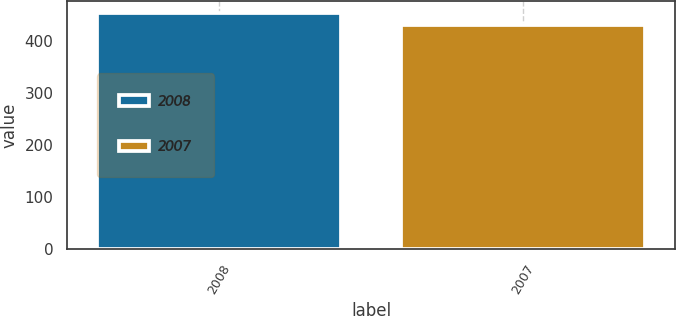<chart> <loc_0><loc_0><loc_500><loc_500><bar_chart><fcel>2008<fcel>2007<nl><fcel>455<fcel>432<nl></chart> 